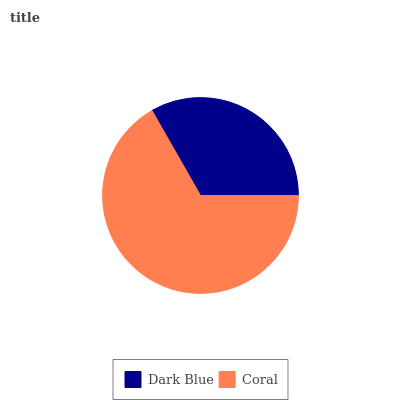Is Dark Blue the minimum?
Answer yes or no. Yes. Is Coral the maximum?
Answer yes or no. Yes. Is Coral the minimum?
Answer yes or no. No. Is Coral greater than Dark Blue?
Answer yes or no. Yes. Is Dark Blue less than Coral?
Answer yes or no. Yes. Is Dark Blue greater than Coral?
Answer yes or no. No. Is Coral less than Dark Blue?
Answer yes or no. No. Is Coral the high median?
Answer yes or no. Yes. Is Dark Blue the low median?
Answer yes or no. Yes. Is Dark Blue the high median?
Answer yes or no. No. Is Coral the low median?
Answer yes or no. No. 